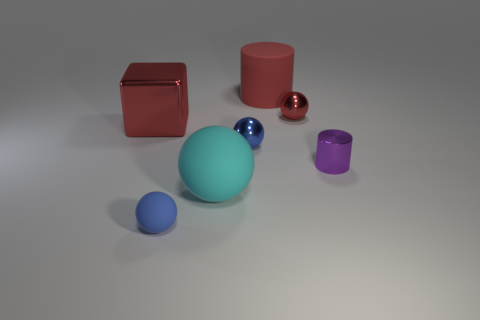Imagine these objects are part of a game, what could be the rules? If these objects were part of a game, the rules might be: Use the sphere as a ball to knock over the cylinders in the fewest rolls possible, the cube represents a die that dictates the number of attempts, and the smaller balls could be used as score multipliers based on their rarity and difficulty to hit. 